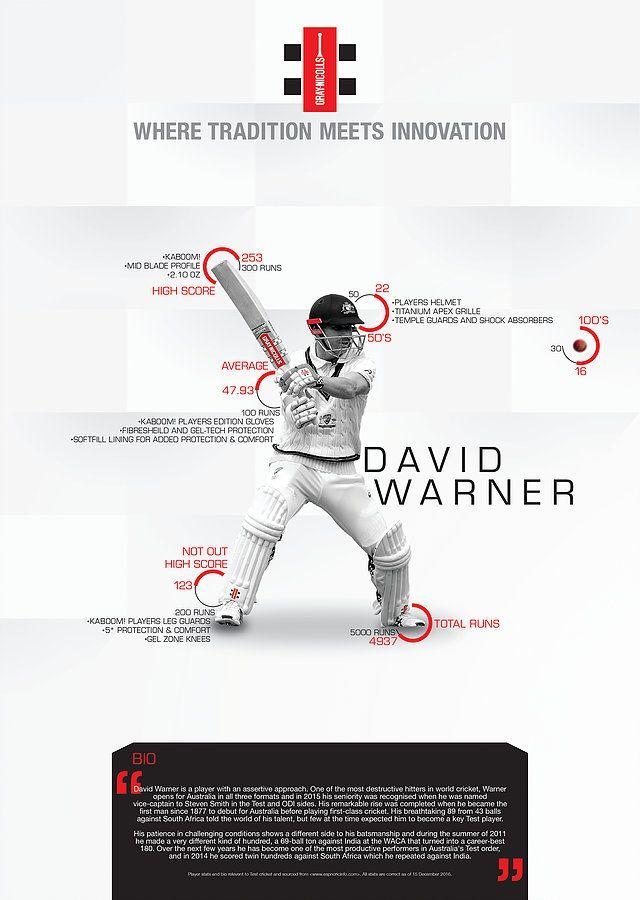Highlight a few significant elements in this photo. The total number of runs scored by David Warner is 4937. 